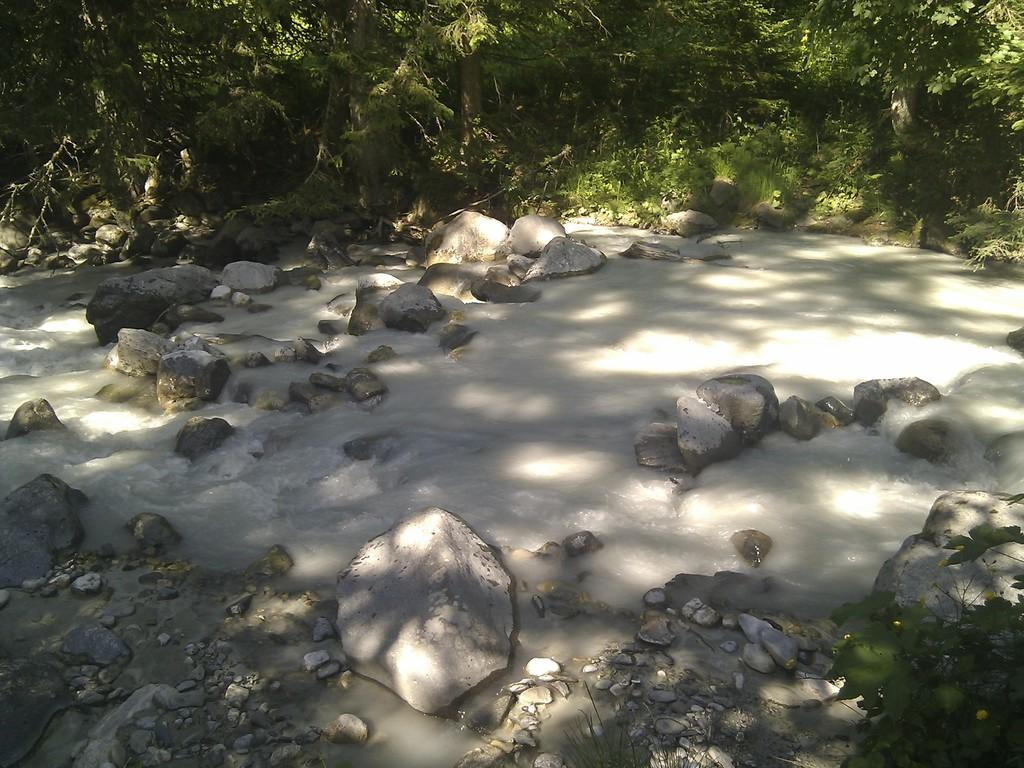What is on the rocks in the image? There is water on the rocks in the image. What surrounds the water in the image? There are rocks around the water in the image. What type of vegetation can be seen in the image? There are plants and trees in the image. Can you see a tramp performing tricks near the water in the image? There is no tramp performing tricks in the image; it features water on rocks, surrounded by more rocks, with plants and trees nearby. Is there a squirrel climbing one of the trees in the image? There is no squirrel present in the image; it only features water on rocks, surrounded by more rocks, with plants and trees nearby. 